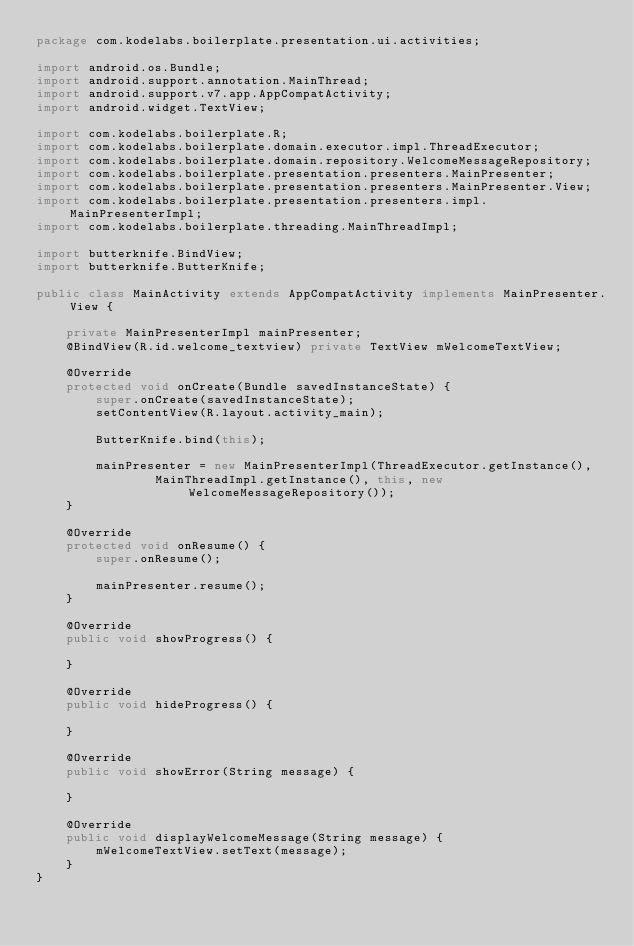Convert code to text. <code><loc_0><loc_0><loc_500><loc_500><_Java_>package com.kodelabs.boilerplate.presentation.ui.activities;

import android.os.Bundle;
import android.support.annotation.MainThread;
import android.support.v7.app.AppCompatActivity;
import android.widget.TextView;

import com.kodelabs.boilerplate.R;
import com.kodelabs.boilerplate.domain.executor.impl.ThreadExecutor;
import com.kodelabs.boilerplate.domain.repository.WelcomeMessageRepository;
import com.kodelabs.boilerplate.presentation.presenters.MainPresenter;
import com.kodelabs.boilerplate.presentation.presenters.MainPresenter.View;
import com.kodelabs.boilerplate.presentation.presenters.impl.MainPresenterImpl;
import com.kodelabs.boilerplate.threading.MainThreadImpl;

import butterknife.BindView;
import butterknife.ButterKnife;

public class MainActivity extends AppCompatActivity implements MainPresenter.View {

    private MainPresenterImpl mainPresenter;
    @BindView(R.id.welcome_textview) private TextView mWelcomeTextView;

    @Override
    protected void onCreate(Bundle savedInstanceState) {
        super.onCreate(savedInstanceState);
        setContentView(R.layout.activity_main);

        ButterKnife.bind(this);

        mainPresenter = new MainPresenterImpl(ThreadExecutor.getInstance(),
                MainThreadImpl.getInstance(), this, new WelcomeMessageRepository());
    }

    @Override
    protected void onResume() {
        super.onResume();

        mainPresenter.resume();
    }

    @Override
    public void showProgress() {

    }

    @Override
    public void hideProgress() {

    }

    @Override
    public void showError(String message) {

    }

    @Override
    public void displayWelcomeMessage(String message) {
        mWelcomeTextView.setText(message);
    }
}
</code> 